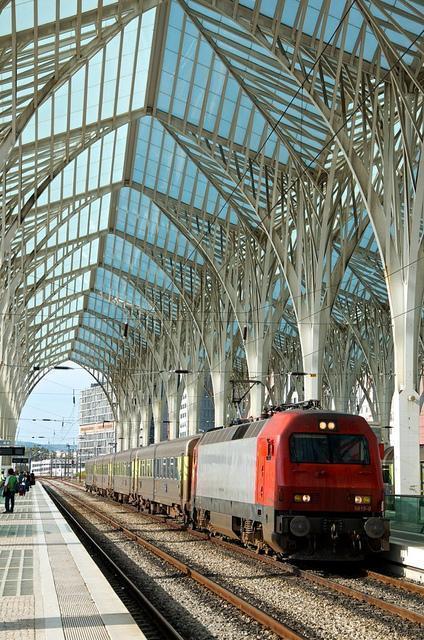How many lights are lit up above the engineers window on the train?
Give a very brief answer. 2. 